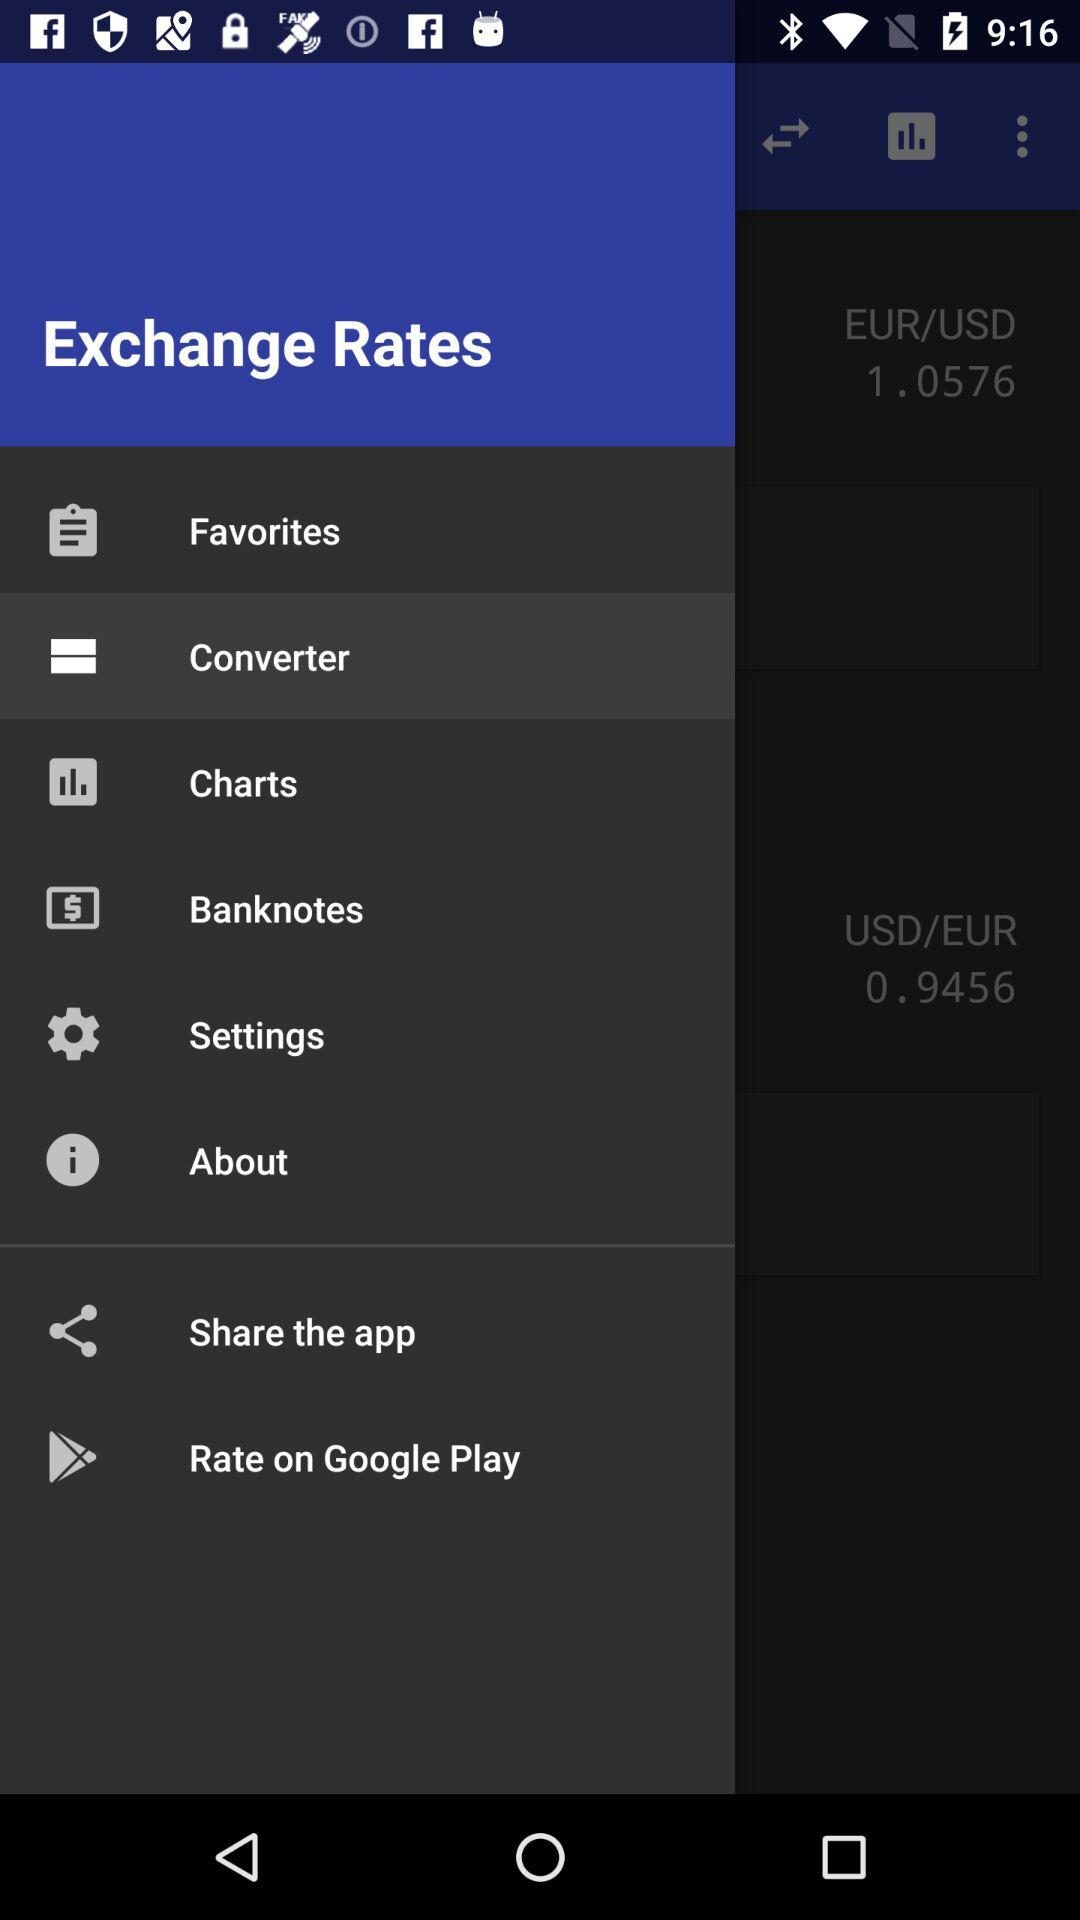What is the difference between the EUR/USD and USD/EUR exchange rates?
Answer the question using a single word or phrase. 0.112 